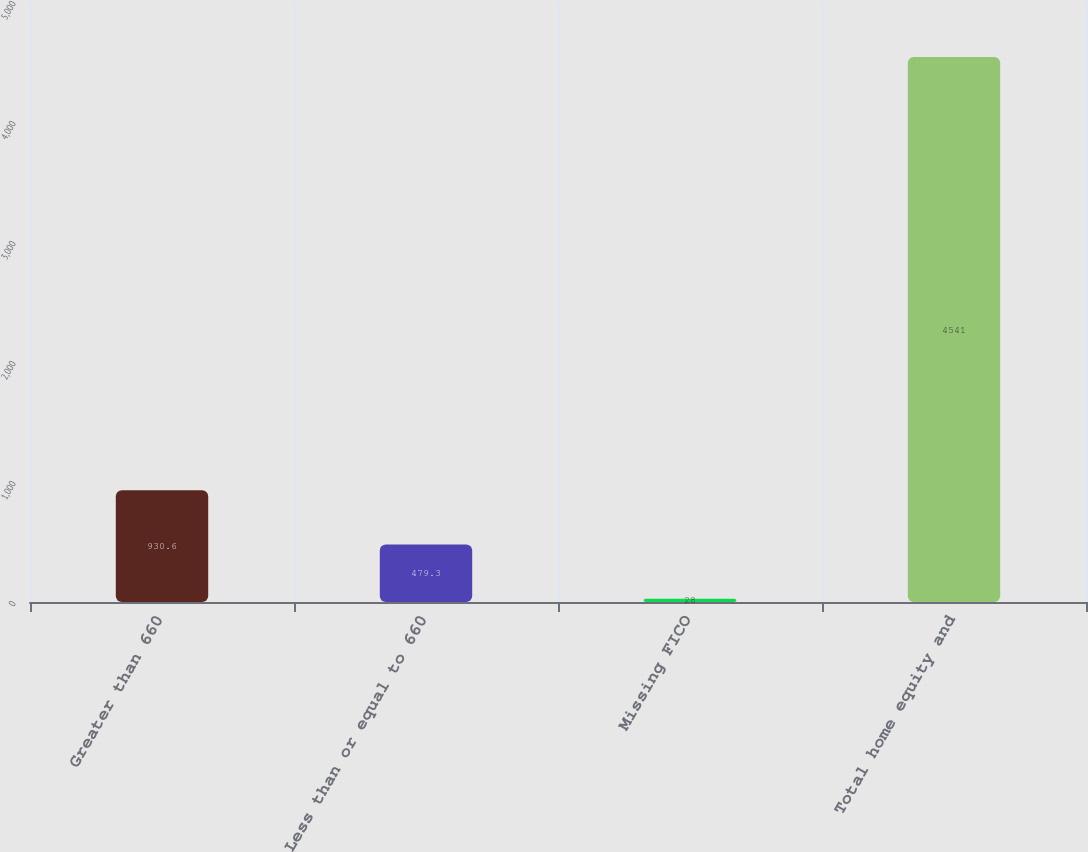Convert chart. <chart><loc_0><loc_0><loc_500><loc_500><bar_chart><fcel>Greater than 660<fcel>Less than or equal to 660<fcel>Missing FICO<fcel>Total home equity and<nl><fcel>930.6<fcel>479.3<fcel>28<fcel>4541<nl></chart> 